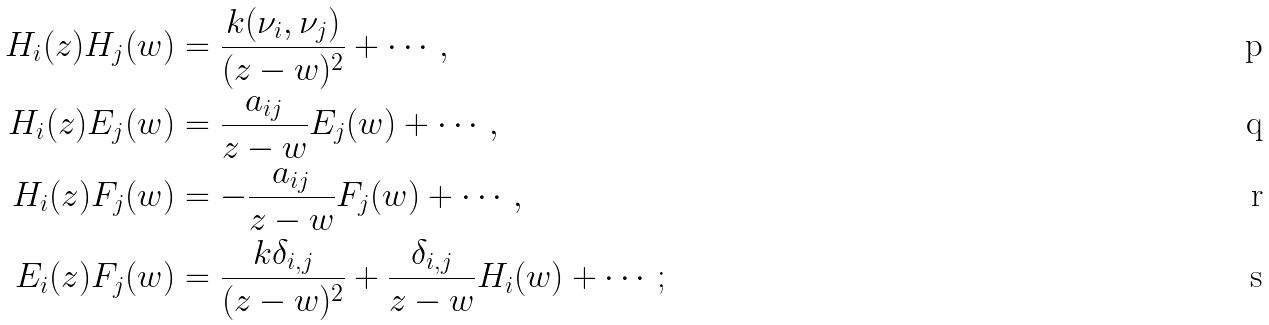<formula> <loc_0><loc_0><loc_500><loc_500>H _ { i } ( z ) H _ { j } ( w ) & = \frac { k ( \nu _ { i } , \nu _ { j } ) } { ( z - w ) ^ { 2 } } + \cdots , \\ H _ { i } ( z ) E _ { j } ( w ) & = \frac { a _ { i j } } { z - w } E _ { j } ( w ) + \cdots , \\ H _ { i } ( z ) F _ { j } ( w ) & = - \frac { a _ { i j } } { z - w } F _ { j } ( w ) + \cdots , \\ E _ { i } ( z ) F _ { j } ( w ) & = \frac { k \delta _ { i , j } } { ( z - w ) ^ { 2 } } + \frac { \delta _ { i , j } } { z - w } H _ { i } ( w ) + \cdots ;</formula> 